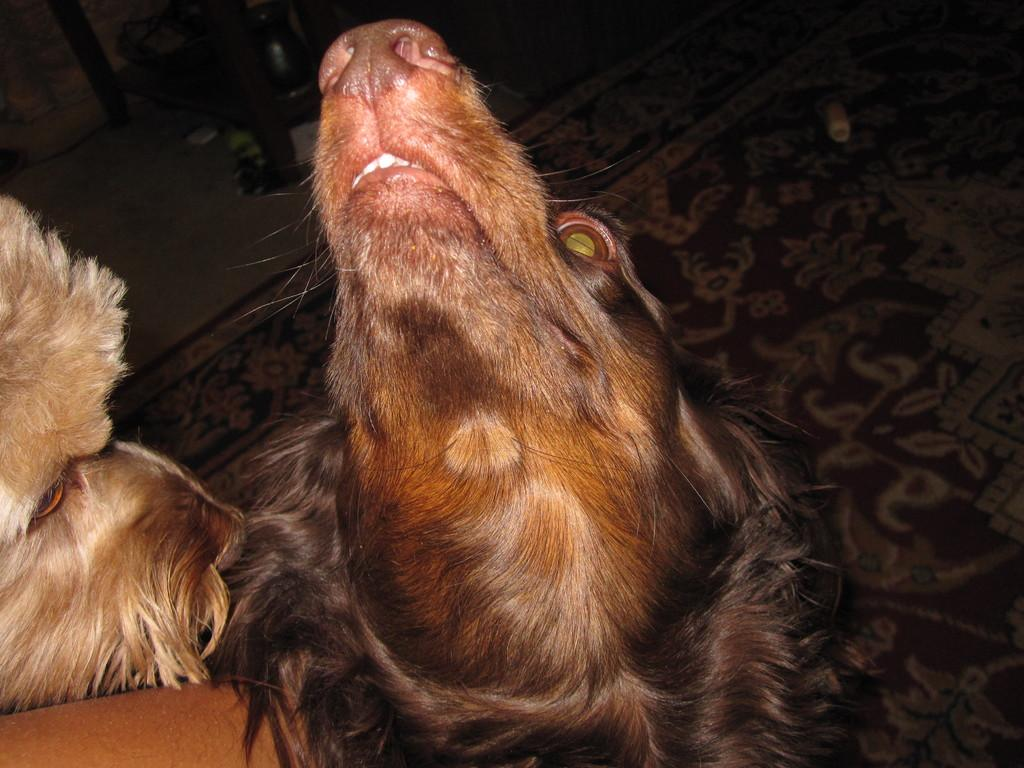What type of animal is in the image? There is a brown dog in the image. What is the brown dog doing in the image? The brown dog is looking up and aside. What other dog-related feature is present in the image? There is a cream-colored dog face in the image. Where is the cream-colored dog face located in relation to the brown dog? The cream-colored dog face is beside the brown dog. What is on the floor in the image? There is a floor mat visible in the image. What is the dog coughing up in the image? There is no indication in the image that the dog is coughing or has anything to cough up. 